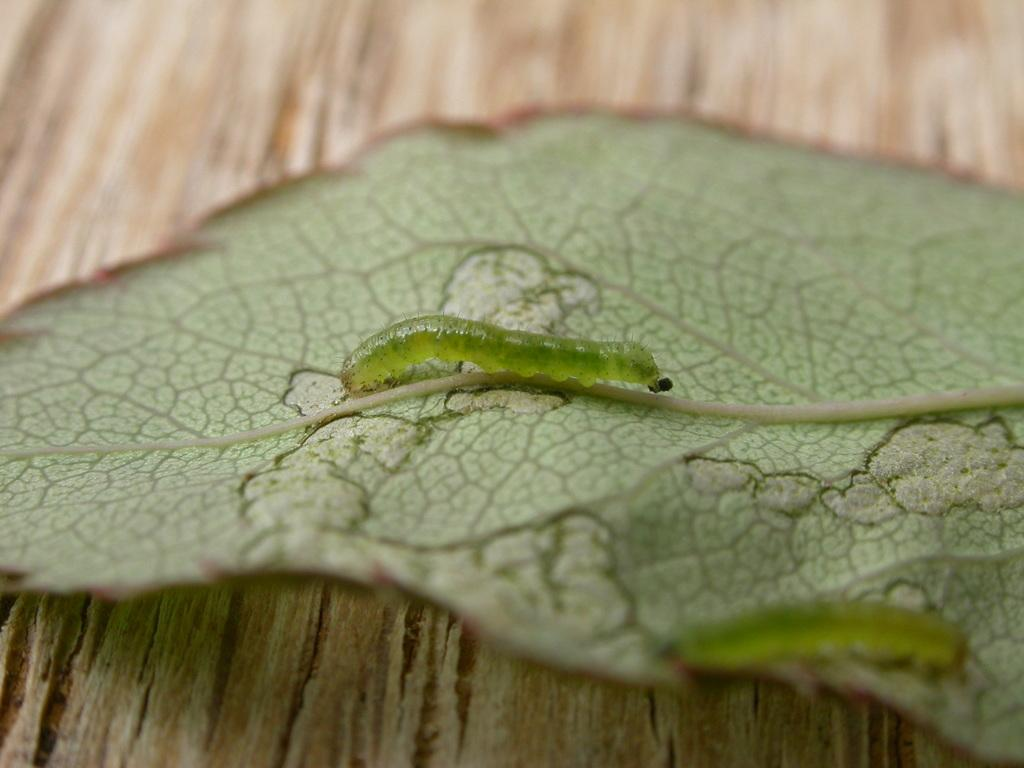What type of creatures can be seen in the image? There are insects in the image. Where are the insects located? The insects are on a leaf. What is the leaf placed on? The leaf is placed on a surface. What type of pig can be seen in the image? There is no pig present in the image; it features insects on a leaf. How does the fowl interact with the insects in the image? There is no fowl present in the image, so it cannot interact with the insects. 